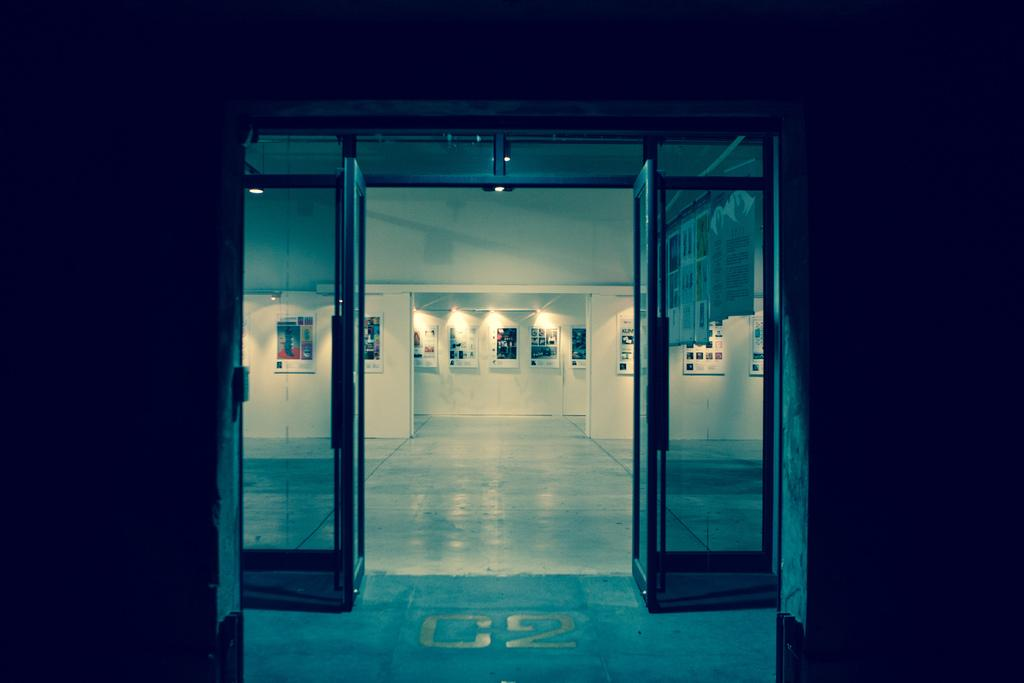What type of doors are present in the image? There are glass doors in the image. What is behind the glass doors? There are walls with boards behind the glass doors. What can be seen at the top of the image? There are lights visible at the top of the image. How does the slope affect the washing process in the image? There is no slope or washing process present in the image. 